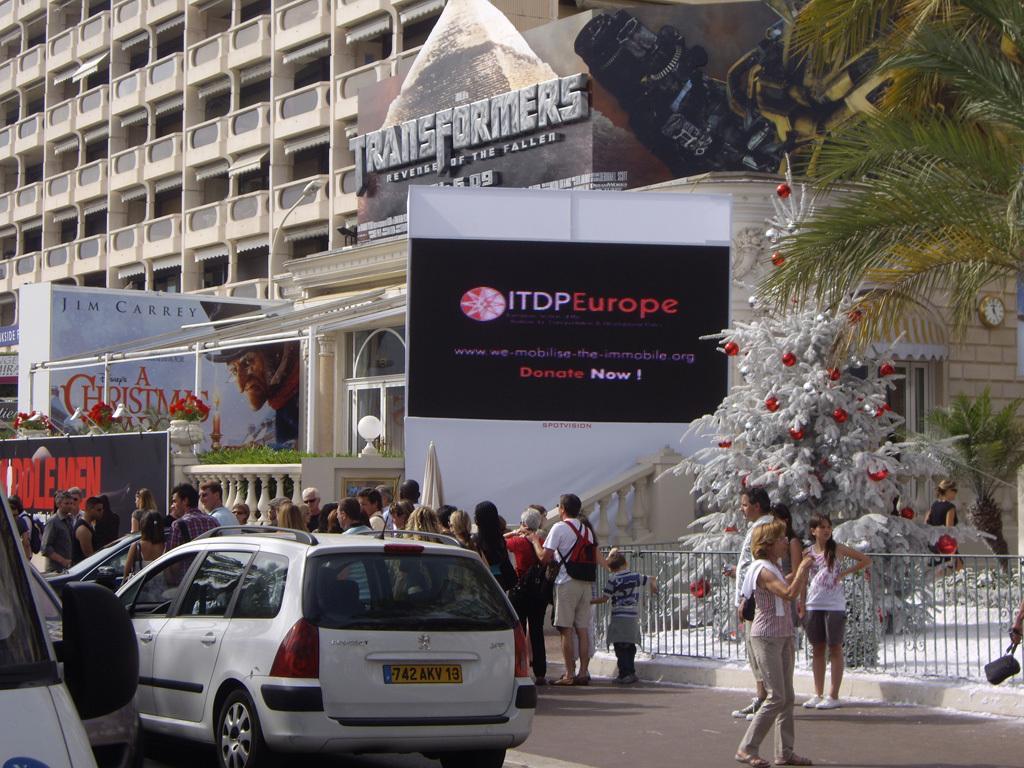In one or two sentences, can you explain what this image depicts? In this picture we can see vehicles and a group of people on the road. In the background we can see banners, fence, trees, window, clock, building, plants, flowers and some objects. 